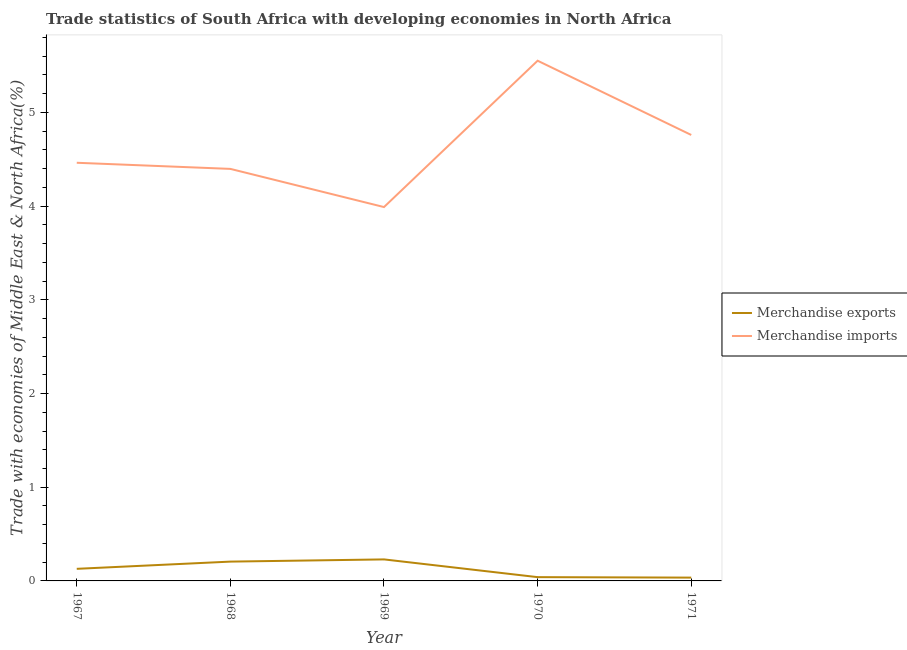Does the line corresponding to merchandise imports intersect with the line corresponding to merchandise exports?
Provide a short and direct response. No. What is the merchandise exports in 1968?
Make the answer very short. 0.21. Across all years, what is the maximum merchandise imports?
Offer a very short reply. 5.55. Across all years, what is the minimum merchandise exports?
Keep it short and to the point. 0.04. In which year was the merchandise exports maximum?
Provide a short and direct response. 1969. What is the total merchandise exports in the graph?
Your answer should be very brief. 0.64. What is the difference between the merchandise exports in 1969 and that in 1970?
Offer a terse response. 0.19. What is the difference between the merchandise exports in 1971 and the merchandise imports in 1967?
Offer a terse response. -4.43. What is the average merchandise imports per year?
Provide a succinct answer. 4.63. In the year 1969, what is the difference between the merchandise imports and merchandise exports?
Keep it short and to the point. 3.76. In how many years, is the merchandise exports greater than 4.2 %?
Give a very brief answer. 0. What is the ratio of the merchandise exports in 1970 to that in 1971?
Keep it short and to the point. 1.14. Is the merchandise exports in 1968 less than that in 1971?
Offer a very short reply. No. Is the difference between the merchandise imports in 1970 and 1971 greater than the difference between the merchandise exports in 1970 and 1971?
Offer a terse response. Yes. What is the difference between the highest and the second highest merchandise exports?
Your response must be concise. 0.02. What is the difference between the highest and the lowest merchandise imports?
Ensure brevity in your answer.  1.56. Is the merchandise exports strictly less than the merchandise imports over the years?
Offer a terse response. Yes. How many lines are there?
Ensure brevity in your answer.  2. What is the difference between two consecutive major ticks on the Y-axis?
Offer a very short reply. 1. Are the values on the major ticks of Y-axis written in scientific E-notation?
Ensure brevity in your answer.  No. Does the graph contain grids?
Your answer should be compact. No. How many legend labels are there?
Your response must be concise. 2. What is the title of the graph?
Your answer should be very brief. Trade statistics of South Africa with developing economies in North Africa. Does "Forest land" appear as one of the legend labels in the graph?
Your answer should be compact. No. What is the label or title of the Y-axis?
Your answer should be very brief. Trade with economies of Middle East & North Africa(%). What is the Trade with economies of Middle East & North Africa(%) in Merchandise exports in 1967?
Give a very brief answer. 0.13. What is the Trade with economies of Middle East & North Africa(%) of Merchandise imports in 1967?
Make the answer very short. 4.46. What is the Trade with economies of Middle East & North Africa(%) in Merchandise exports in 1968?
Give a very brief answer. 0.21. What is the Trade with economies of Middle East & North Africa(%) of Merchandise imports in 1968?
Keep it short and to the point. 4.4. What is the Trade with economies of Middle East & North Africa(%) in Merchandise exports in 1969?
Ensure brevity in your answer.  0.23. What is the Trade with economies of Middle East & North Africa(%) of Merchandise imports in 1969?
Provide a short and direct response. 3.99. What is the Trade with economies of Middle East & North Africa(%) of Merchandise exports in 1970?
Your answer should be very brief. 0.04. What is the Trade with economies of Middle East & North Africa(%) of Merchandise imports in 1970?
Offer a terse response. 5.55. What is the Trade with economies of Middle East & North Africa(%) of Merchandise exports in 1971?
Provide a succinct answer. 0.04. What is the Trade with economies of Middle East & North Africa(%) in Merchandise imports in 1971?
Your response must be concise. 4.76. Across all years, what is the maximum Trade with economies of Middle East & North Africa(%) in Merchandise exports?
Provide a succinct answer. 0.23. Across all years, what is the maximum Trade with economies of Middle East & North Africa(%) in Merchandise imports?
Make the answer very short. 5.55. Across all years, what is the minimum Trade with economies of Middle East & North Africa(%) of Merchandise exports?
Provide a succinct answer. 0.04. Across all years, what is the minimum Trade with economies of Middle East & North Africa(%) of Merchandise imports?
Your response must be concise. 3.99. What is the total Trade with economies of Middle East & North Africa(%) of Merchandise exports in the graph?
Your response must be concise. 0.64. What is the total Trade with economies of Middle East & North Africa(%) of Merchandise imports in the graph?
Your answer should be very brief. 23.16. What is the difference between the Trade with economies of Middle East & North Africa(%) in Merchandise exports in 1967 and that in 1968?
Ensure brevity in your answer.  -0.08. What is the difference between the Trade with economies of Middle East & North Africa(%) in Merchandise imports in 1967 and that in 1968?
Ensure brevity in your answer.  0.07. What is the difference between the Trade with economies of Middle East & North Africa(%) of Merchandise exports in 1967 and that in 1969?
Provide a short and direct response. -0.1. What is the difference between the Trade with economies of Middle East & North Africa(%) in Merchandise imports in 1967 and that in 1969?
Provide a succinct answer. 0.47. What is the difference between the Trade with economies of Middle East & North Africa(%) of Merchandise exports in 1967 and that in 1970?
Provide a short and direct response. 0.09. What is the difference between the Trade with economies of Middle East & North Africa(%) of Merchandise imports in 1967 and that in 1970?
Offer a very short reply. -1.09. What is the difference between the Trade with economies of Middle East & North Africa(%) in Merchandise exports in 1967 and that in 1971?
Ensure brevity in your answer.  0.09. What is the difference between the Trade with economies of Middle East & North Africa(%) of Merchandise imports in 1967 and that in 1971?
Your response must be concise. -0.3. What is the difference between the Trade with economies of Middle East & North Africa(%) of Merchandise exports in 1968 and that in 1969?
Ensure brevity in your answer.  -0.02. What is the difference between the Trade with economies of Middle East & North Africa(%) of Merchandise imports in 1968 and that in 1969?
Keep it short and to the point. 0.41. What is the difference between the Trade with economies of Middle East & North Africa(%) of Merchandise exports in 1968 and that in 1970?
Provide a succinct answer. 0.17. What is the difference between the Trade with economies of Middle East & North Africa(%) of Merchandise imports in 1968 and that in 1970?
Your response must be concise. -1.15. What is the difference between the Trade with economies of Middle East & North Africa(%) in Merchandise exports in 1968 and that in 1971?
Ensure brevity in your answer.  0.17. What is the difference between the Trade with economies of Middle East & North Africa(%) in Merchandise imports in 1968 and that in 1971?
Your answer should be compact. -0.36. What is the difference between the Trade with economies of Middle East & North Africa(%) in Merchandise exports in 1969 and that in 1970?
Your answer should be very brief. 0.19. What is the difference between the Trade with economies of Middle East & North Africa(%) in Merchandise imports in 1969 and that in 1970?
Give a very brief answer. -1.56. What is the difference between the Trade with economies of Middle East & North Africa(%) in Merchandise exports in 1969 and that in 1971?
Offer a terse response. 0.19. What is the difference between the Trade with economies of Middle East & North Africa(%) in Merchandise imports in 1969 and that in 1971?
Offer a terse response. -0.77. What is the difference between the Trade with economies of Middle East & North Africa(%) of Merchandise exports in 1970 and that in 1971?
Your response must be concise. 0.01. What is the difference between the Trade with economies of Middle East & North Africa(%) of Merchandise imports in 1970 and that in 1971?
Your answer should be compact. 0.79. What is the difference between the Trade with economies of Middle East & North Africa(%) of Merchandise exports in 1967 and the Trade with economies of Middle East & North Africa(%) of Merchandise imports in 1968?
Offer a very short reply. -4.27. What is the difference between the Trade with economies of Middle East & North Africa(%) of Merchandise exports in 1967 and the Trade with economies of Middle East & North Africa(%) of Merchandise imports in 1969?
Provide a short and direct response. -3.86. What is the difference between the Trade with economies of Middle East & North Africa(%) of Merchandise exports in 1967 and the Trade with economies of Middle East & North Africa(%) of Merchandise imports in 1970?
Offer a very short reply. -5.42. What is the difference between the Trade with economies of Middle East & North Africa(%) of Merchandise exports in 1967 and the Trade with economies of Middle East & North Africa(%) of Merchandise imports in 1971?
Ensure brevity in your answer.  -4.63. What is the difference between the Trade with economies of Middle East & North Africa(%) of Merchandise exports in 1968 and the Trade with economies of Middle East & North Africa(%) of Merchandise imports in 1969?
Your answer should be compact. -3.78. What is the difference between the Trade with economies of Middle East & North Africa(%) of Merchandise exports in 1968 and the Trade with economies of Middle East & North Africa(%) of Merchandise imports in 1970?
Provide a short and direct response. -5.35. What is the difference between the Trade with economies of Middle East & North Africa(%) of Merchandise exports in 1968 and the Trade with economies of Middle East & North Africa(%) of Merchandise imports in 1971?
Your answer should be compact. -4.55. What is the difference between the Trade with economies of Middle East & North Africa(%) of Merchandise exports in 1969 and the Trade with economies of Middle East & North Africa(%) of Merchandise imports in 1970?
Your answer should be very brief. -5.32. What is the difference between the Trade with economies of Middle East & North Africa(%) in Merchandise exports in 1969 and the Trade with economies of Middle East & North Africa(%) in Merchandise imports in 1971?
Ensure brevity in your answer.  -4.53. What is the difference between the Trade with economies of Middle East & North Africa(%) of Merchandise exports in 1970 and the Trade with economies of Middle East & North Africa(%) of Merchandise imports in 1971?
Your answer should be compact. -4.72. What is the average Trade with economies of Middle East & North Africa(%) of Merchandise exports per year?
Ensure brevity in your answer.  0.13. What is the average Trade with economies of Middle East & North Africa(%) in Merchandise imports per year?
Your answer should be compact. 4.63. In the year 1967, what is the difference between the Trade with economies of Middle East & North Africa(%) in Merchandise exports and Trade with economies of Middle East & North Africa(%) in Merchandise imports?
Your answer should be very brief. -4.33. In the year 1968, what is the difference between the Trade with economies of Middle East & North Africa(%) in Merchandise exports and Trade with economies of Middle East & North Africa(%) in Merchandise imports?
Offer a terse response. -4.19. In the year 1969, what is the difference between the Trade with economies of Middle East & North Africa(%) in Merchandise exports and Trade with economies of Middle East & North Africa(%) in Merchandise imports?
Provide a short and direct response. -3.76. In the year 1970, what is the difference between the Trade with economies of Middle East & North Africa(%) of Merchandise exports and Trade with economies of Middle East & North Africa(%) of Merchandise imports?
Provide a short and direct response. -5.51. In the year 1971, what is the difference between the Trade with economies of Middle East & North Africa(%) in Merchandise exports and Trade with economies of Middle East & North Africa(%) in Merchandise imports?
Provide a short and direct response. -4.72. What is the ratio of the Trade with economies of Middle East & North Africa(%) in Merchandise exports in 1967 to that in 1968?
Ensure brevity in your answer.  0.63. What is the ratio of the Trade with economies of Middle East & North Africa(%) in Merchandise imports in 1967 to that in 1968?
Offer a very short reply. 1.01. What is the ratio of the Trade with economies of Middle East & North Africa(%) of Merchandise exports in 1967 to that in 1969?
Ensure brevity in your answer.  0.56. What is the ratio of the Trade with economies of Middle East & North Africa(%) in Merchandise imports in 1967 to that in 1969?
Your answer should be compact. 1.12. What is the ratio of the Trade with economies of Middle East & North Africa(%) in Merchandise exports in 1967 to that in 1970?
Provide a short and direct response. 3.2. What is the ratio of the Trade with economies of Middle East & North Africa(%) in Merchandise imports in 1967 to that in 1970?
Offer a terse response. 0.8. What is the ratio of the Trade with economies of Middle East & North Africa(%) of Merchandise exports in 1967 to that in 1971?
Provide a short and direct response. 3.66. What is the ratio of the Trade with economies of Middle East & North Africa(%) in Merchandise imports in 1967 to that in 1971?
Keep it short and to the point. 0.94. What is the ratio of the Trade with economies of Middle East & North Africa(%) in Merchandise exports in 1968 to that in 1969?
Provide a succinct answer. 0.9. What is the ratio of the Trade with economies of Middle East & North Africa(%) in Merchandise imports in 1968 to that in 1969?
Your answer should be compact. 1.1. What is the ratio of the Trade with economies of Middle East & North Africa(%) of Merchandise exports in 1968 to that in 1970?
Your answer should be very brief. 5.12. What is the ratio of the Trade with economies of Middle East & North Africa(%) of Merchandise imports in 1968 to that in 1970?
Your response must be concise. 0.79. What is the ratio of the Trade with economies of Middle East & North Africa(%) in Merchandise exports in 1968 to that in 1971?
Your answer should be compact. 5.84. What is the ratio of the Trade with economies of Middle East & North Africa(%) in Merchandise imports in 1968 to that in 1971?
Keep it short and to the point. 0.92. What is the ratio of the Trade with economies of Middle East & North Africa(%) in Merchandise exports in 1969 to that in 1970?
Your answer should be compact. 5.7. What is the ratio of the Trade with economies of Middle East & North Africa(%) of Merchandise imports in 1969 to that in 1970?
Your answer should be compact. 0.72. What is the ratio of the Trade with economies of Middle East & North Africa(%) of Merchandise exports in 1969 to that in 1971?
Your response must be concise. 6.51. What is the ratio of the Trade with economies of Middle East & North Africa(%) in Merchandise imports in 1969 to that in 1971?
Your answer should be compact. 0.84. What is the ratio of the Trade with economies of Middle East & North Africa(%) in Merchandise exports in 1970 to that in 1971?
Your response must be concise. 1.14. What is the ratio of the Trade with economies of Middle East & North Africa(%) in Merchandise imports in 1970 to that in 1971?
Provide a succinct answer. 1.17. What is the difference between the highest and the second highest Trade with economies of Middle East & North Africa(%) of Merchandise exports?
Offer a terse response. 0.02. What is the difference between the highest and the second highest Trade with economies of Middle East & North Africa(%) in Merchandise imports?
Your answer should be very brief. 0.79. What is the difference between the highest and the lowest Trade with economies of Middle East & North Africa(%) of Merchandise exports?
Your response must be concise. 0.19. What is the difference between the highest and the lowest Trade with economies of Middle East & North Africa(%) of Merchandise imports?
Your response must be concise. 1.56. 